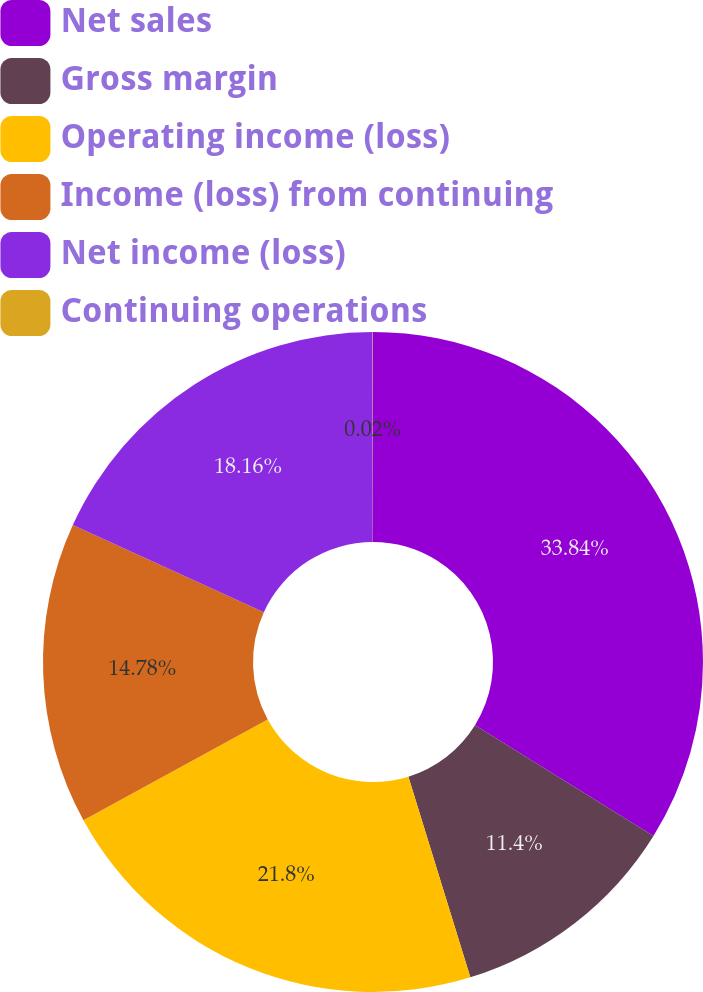<chart> <loc_0><loc_0><loc_500><loc_500><pie_chart><fcel>Net sales<fcel>Gross margin<fcel>Operating income (loss)<fcel>Income (loss) from continuing<fcel>Net income (loss)<fcel>Continuing operations<nl><fcel>33.83%<fcel>11.4%<fcel>21.8%<fcel>14.78%<fcel>18.16%<fcel>0.02%<nl></chart> 